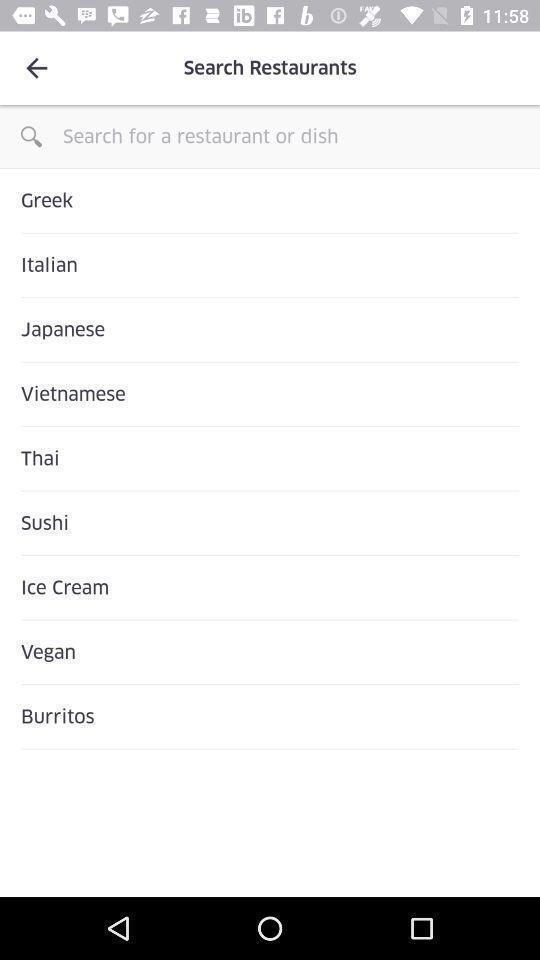Explain what's happening in this screen capture. Search bar to search for restaurants and dish. 